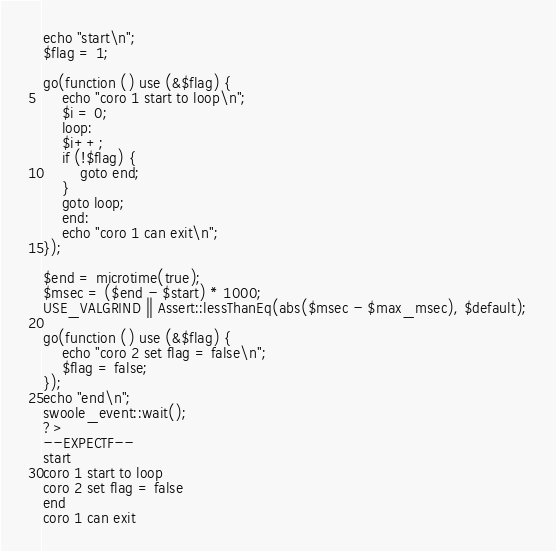Convert code to text. <code><loc_0><loc_0><loc_500><loc_500><_PHP_>echo "start\n";
$flag = 1;

go(function () use (&$flag) {
    echo "coro 1 start to loop\n";
    $i = 0;
    loop:
    $i++;
    if (!$flag) {
        goto end;
    }
    goto loop;
    end:
    echo "coro 1 can exit\n";
});

$end = microtime(true);
$msec = ($end - $start) * 1000;
USE_VALGRIND || Assert::lessThanEq(abs($msec - $max_msec), $default);

go(function () use (&$flag) {
    echo "coro 2 set flag = false\n";
    $flag = false;
});
echo "end\n";
swoole_event::wait();
?>
--EXPECTF--
start
coro 1 start to loop
coro 2 set flag = false
end
coro 1 can exit
</code> 